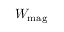<formula> <loc_0><loc_0><loc_500><loc_500>W _ { m a g }</formula> 